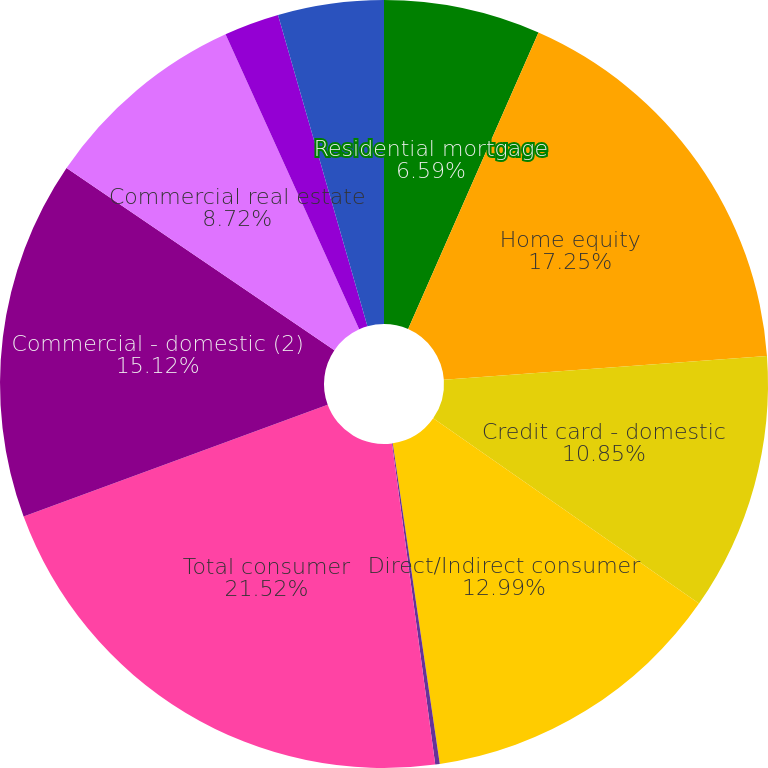Convert chart to OTSL. <chart><loc_0><loc_0><loc_500><loc_500><pie_chart><fcel>Residential mortgage<fcel>Home equity<fcel>Credit card - domestic<fcel>Direct/Indirect consumer<fcel>Other consumer<fcel>Total consumer<fcel>Commercial - domestic (2)<fcel>Commercial real estate<fcel>Commercial lease financing<fcel>Commercial - foreign<nl><fcel>6.59%<fcel>17.25%<fcel>10.85%<fcel>12.99%<fcel>0.19%<fcel>21.52%<fcel>15.12%<fcel>8.72%<fcel>2.32%<fcel>4.45%<nl></chart> 